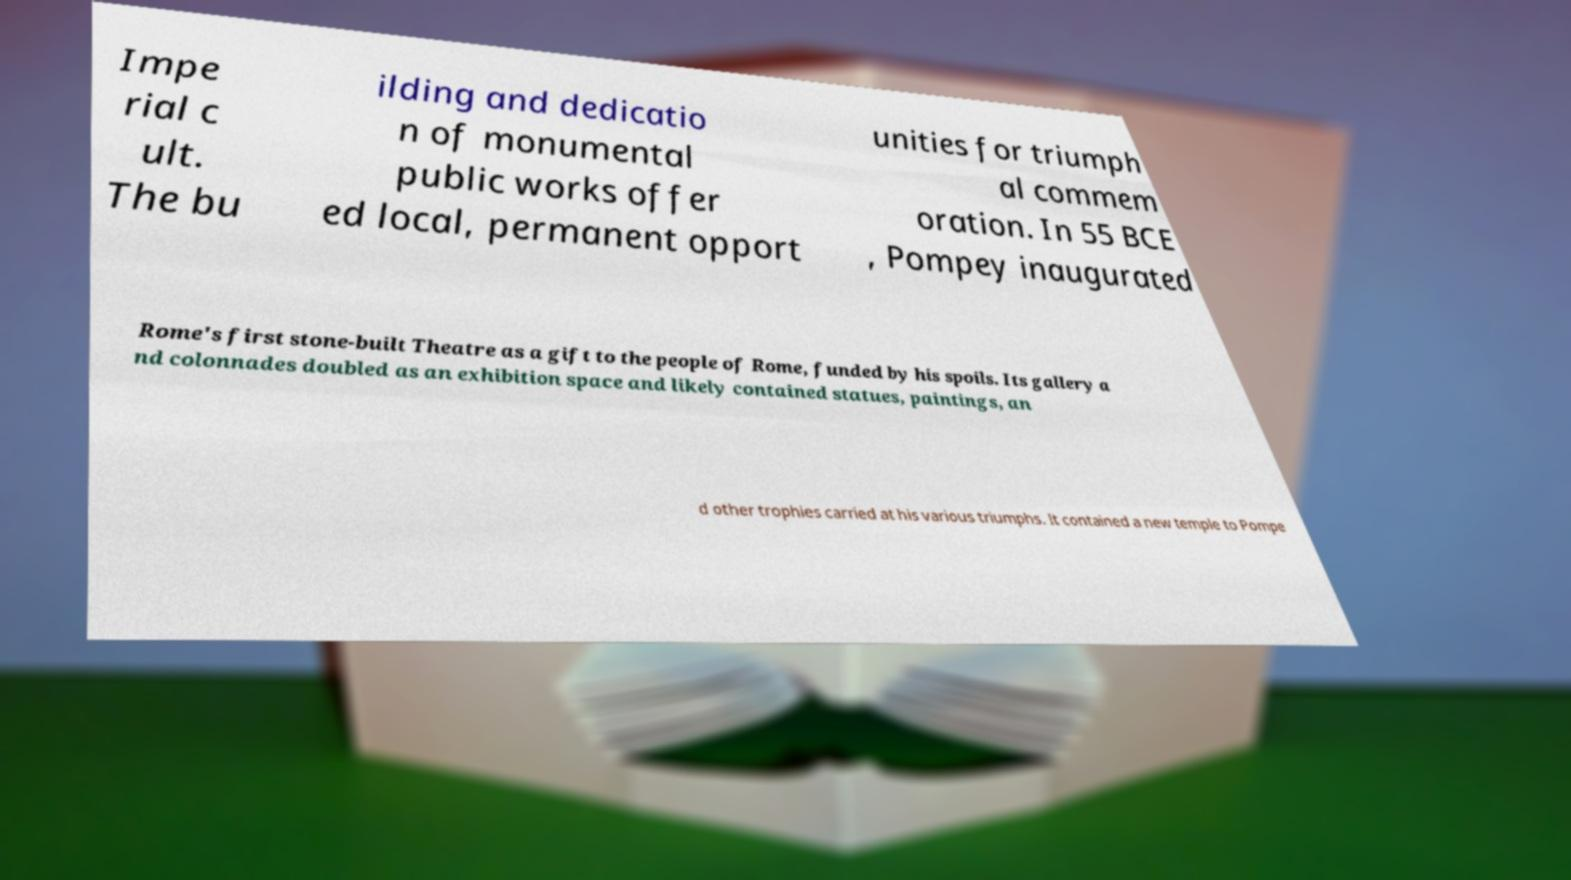Could you assist in decoding the text presented in this image and type it out clearly? Impe rial c ult. The bu ilding and dedicatio n of monumental public works offer ed local, permanent opport unities for triumph al commem oration. In 55 BCE , Pompey inaugurated Rome's first stone-built Theatre as a gift to the people of Rome, funded by his spoils. Its gallery a nd colonnades doubled as an exhibition space and likely contained statues, paintings, an d other trophies carried at his various triumphs. It contained a new temple to Pompe 